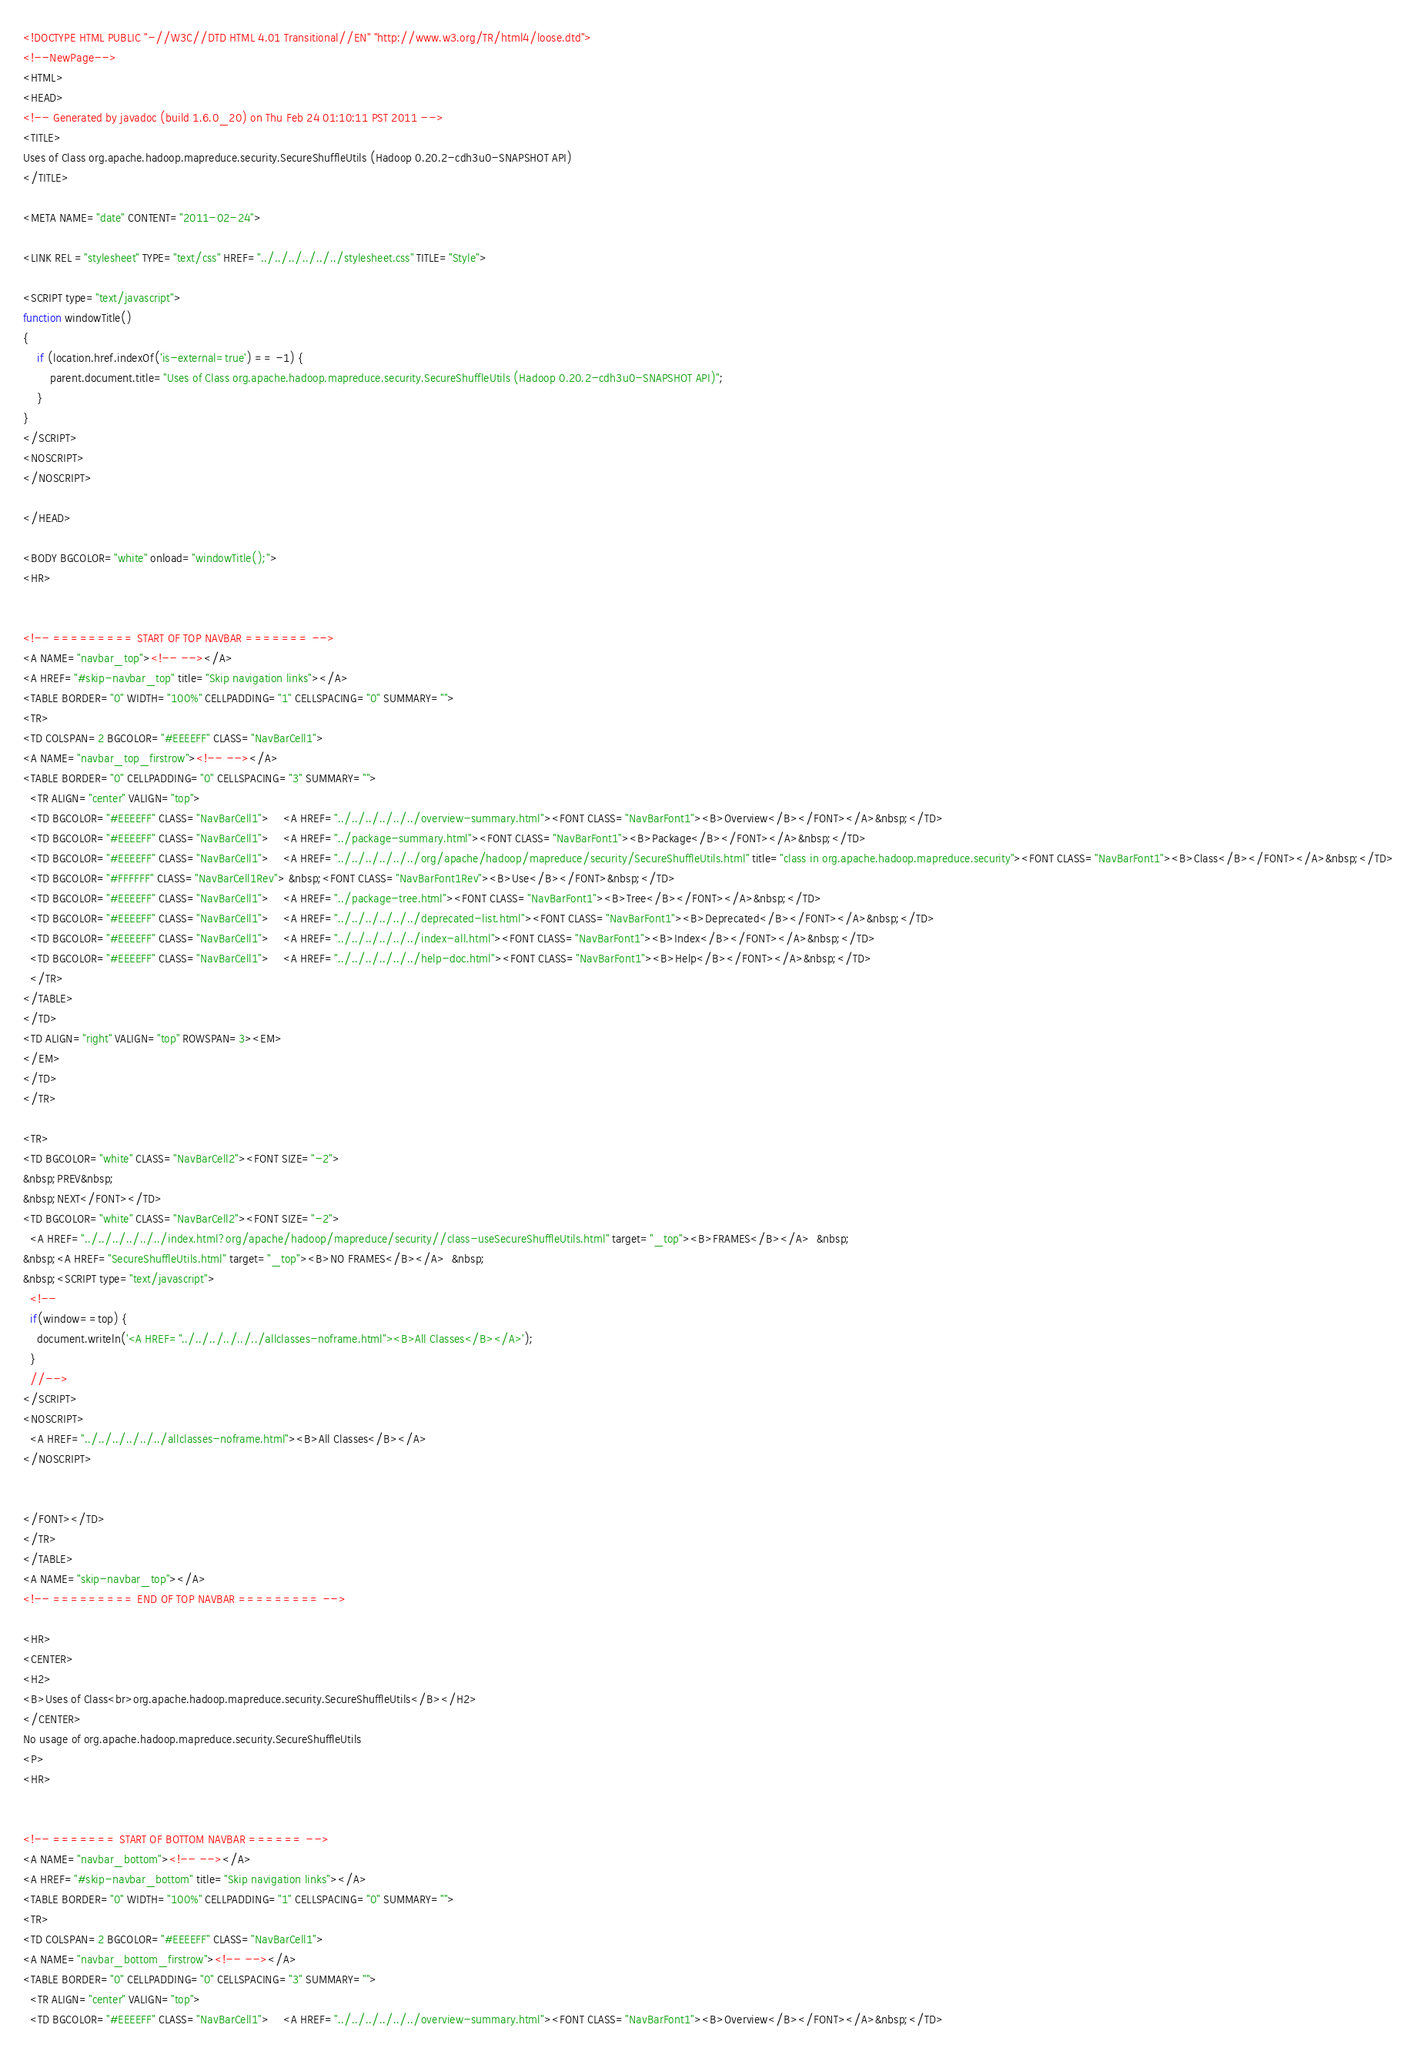Convert code to text. <code><loc_0><loc_0><loc_500><loc_500><_HTML_><!DOCTYPE HTML PUBLIC "-//W3C//DTD HTML 4.01 Transitional//EN" "http://www.w3.org/TR/html4/loose.dtd">
<!--NewPage-->
<HTML>
<HEAD>
<!-- Generated by javadoc (build 1.6.0_20) on Thu Feb 24 01:10:11 PST 2011 -->
<TITLE>
Uses of Class org.apache.hadoop.mapreduce.security.SecureShuffleUtils (Hadoop 0.20.2-cdh3u0-SNAPSHOT API)
</TITLE>

<META NAME="date" CONTENT="2011-02-24">

<LINK REL ="stylesheet" TYPE="text/css" HREF="../../../../../../stylesheet.css" TITLE="Style">

<SCRIPT type="text/javascript">
function windowTitle()
{
    if (location.href.indexOf('is-external=true') == -1) {
        parent.document.title="Uses of Class org.apache.hadoop.mapreduce.security.SecureShuffleUtils (Hadoop 0.20.2-cdh3u0-SNAPSHOT API)";
    }
}
</SCRIPT>
<NOSCRIPT>
</NOSCRIPT>

</HEAD>

<BODY BGCOLOR="white" onload="windowTitle();">
<HR>


<!-- ========= START OF TOP NAVBAR ======= -->
<A NAME="navbar_top"><!-- --></A>
<A HREF="#skip-navbar_top" title="Skip navigation links"></A>
<TABLE BORDER="0" WIDTH="100%" CELLPADDING="1" CELLSPACING="0" SUMMARY="">
<TR>
<TD COLSPAN=2 BGCOLOR="#EEEEFF" CLASS="NavBarCell1">
<A NAME="navbar_top_firstrow"><!-- --></A>
<TABLE BORDER="0" CELLPADDING="0" CELLSPACING="3" SUMMARY="">
  <TR ALIGN="center" VALIGN="top">
  <TD BGCOLOR="#EEEEFF" CLASS="NavBarCell1">    <A HREF="../../../../../../overview-summary.html"><FONT CLASS="NavBarFont1"><B>Overview</B></FONT></A>&nbsp;</TD>
  <TD BGCOLOR="#EEEEFF" CLASS="NavBarCell1">    <A HREF="../package-summary.html"><FONT CLASS="NavBarFont1"><B>Package</B></FONT></A>&nbsp;</TD>
  <TD BGCOLOR="#EEEEFF" CLASS="NavBarCell1">    <A HREF="../../../../../../org/apache/hadoop/mapreduce/security/SecureShuffleUtils.html" title="class in org.apache.hadoop.mapreduce.security"><FONT CLASS="NavBarFont1"><B>Class</B></FONT></A>&nbsp;</TD>
  <TD BGCOLOR="#FFFFFF" CLASS="NavBarCell1Rev"> &nbsp;<FONT CLASS="NavBarFont1Rev"><B>Use</B></FONT>&nbsp;</TD>
  <TD BGCOLOR="#EEEEFF" CLASS="NavBarCell1">    <A HREF="../package-tree.html"><FONT CLASS="NavBarFont1"><B>Tree</B></FONT></A>&nbsp;</TD>
  <TD BGCOLOR="#EEEEFF" CLASS="NavBarCell1">    <A HREF="../../../../../../deprecated-list.html"><FONT CLASS="NavBarFont1"><B>Deprecated</B></FONT></A>&nbsp;</TD>
  <TD BGCOLOR="#EEEEFF" CLASS="NavBarCell1">    <A HREF="../../../../../../index-all.html"><FONT CLASS="NavBarFont1"><B>Index</B></FONT></A>&nbsp;</TD>
  <TD BGCOLOR="#EEEEFF" CLASS="NavBarCell1">    <A HREF="../../../../../../help-doc.html"><FONT CLASS="NavBarFont1"><B>Help</B></FONT></A>&nbsp;</TD>
  </TR>
</TABLE>
</TD>
<TD ALIGN="right" VALIGN="top" ROWSPAN=3><EM>
</EM>
</TD>
</TR>

<TR>
<TD BGCOLOR="white" CLASS="NavBarCell2"><FONT SIZE="-2">
&nbsp;PREV&nbsp;
&nbsp;NEXT</FONT></TD>
<TD BGCOLOR="white" CLASS="NavBarCell2"><FONT SIZE="-2">
  <A HREF="../../../../../../index.html?org/apache/hadoop/mapreduce/security//class-useSecureShuffleUtils.html" target="_top"><B>FRAMES</B></A>  &nbsp;
&nbsp;<A HREF="SecureShuffleUtils.html" target="_top"><B>NO FRAMES</B></A>  &nbsp;
&nbsp;<SCRIPT type="text/javascript">
  <!--
  if(window==top) {
    document.writeln('<A HREF="../../../../../../allclasses-noframe.html"><B>All Classes</B></A>');
  }
  //-->
</SCRIPT>
<NOSCRIPT>
  <A HREF="../../../../../../allclasses-noframe.html"><B>All Classes</B></A>
</NOSCRIPT>


</FONT></TD>
</TR>
</TABLE>
<A NAME="skip-navbar_top"></A>
<!-- ========= END OF TOP NAVBAR ========= -->

<HR>
<CENTER>
<H2>
<B>Uses of Class<br>org.apache.hadoop.mapreduce.security.SecureShuffleUtils</B></H2>
</CENTER>
No usage of org.apache.hadoop.mapreduce.security.SecureShuffleUtils
<P>
<HR>


<!-- ======= START OF BOTTOM NAVBAR ====== -->
<A NAME="navbar_bottom"><!-- --></A>
<A HREF="#skip-navbar_bottom" title="Skip navigation links"></A>
<TABLE BORDER="0" WIDTH="100%" CELLPADDING="1" CELLSPACING="0" SUMMARY="">
<TR>
<TD COLSPAN=2 BGCOLOR="#EEEEFF" CLASS="NavBarCell1">
<A NAME="navbar_bottom_firstrow"><!-- --></A>
<TABLE BORDER="0" CELLPADDING="0" CELLSPACING="3" SUMMARY="">
  <TR ALIGN="center" VALIGN="top">
  <TD BGCOLOR="#EEEEFF" CLASS="NavBarCell1">    <A HREF="../../../../../../overview-summary.html"><FONT CLASS="NavBarFont1"><B>Overview</B></FONT></A>&nbsp;</TD></code> 